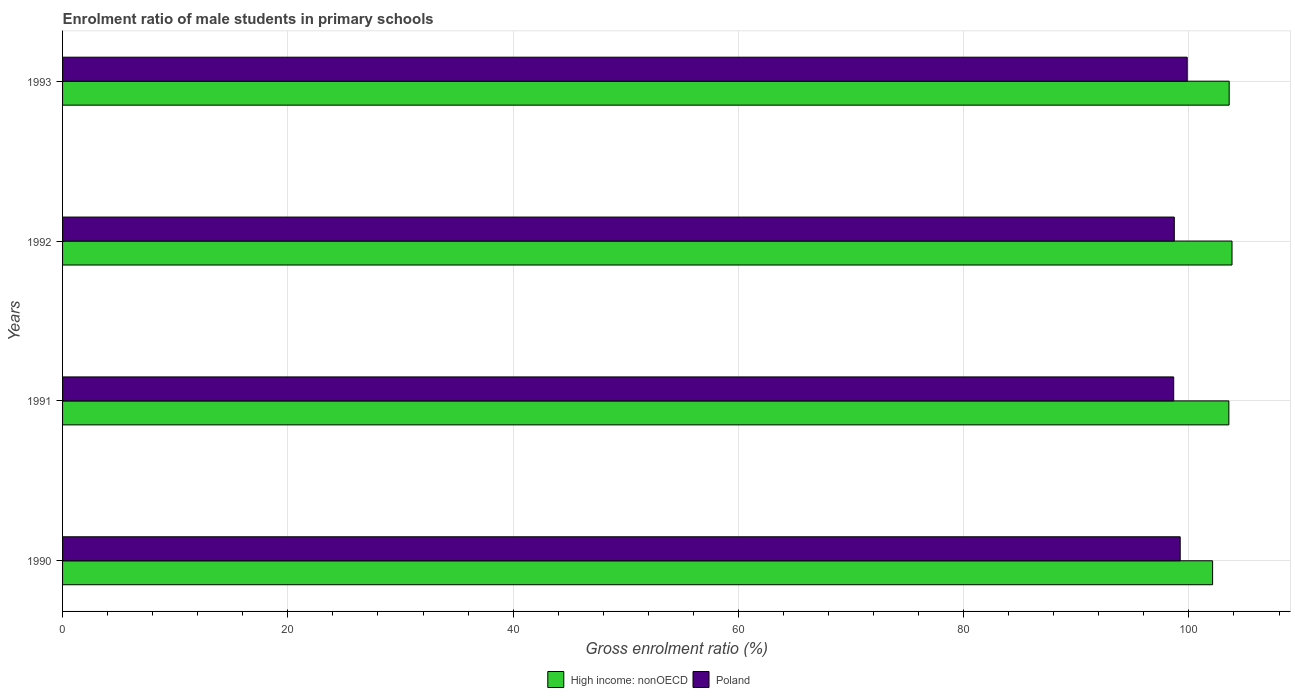How many different coloured bars are there?
Your response must be concise. 2. How many bars are there on the 3rd tick from the bottom?
Give a very brief answer. 2. What is the label of the 4th group of bars from the top?
Keep it short and to the point. 1990. In how many cases, is the number of bars for a given year not equal to the number of legend labels?
Provide a short and direct response. 0. What is the enrolment ratio of male students in primary schools in High income: nonOECD in 1991?
Provide a succinct answer. 103.54. Across all years, what is the maximum enrolment ratio of male students in primary schools in High income: nonOECD?
Ensure brevity in your answer.  103.83. Across all years, what is the minimum enrolment ratio of male students in primary schools in Poland?
Make the answer very short. 98.65. In which year was the enrolment ratio of male students in primary schools in High income: nonOECD maximum?
Your answer should be very brief. 1992. What is the total enrolment ratio of male students in primary schools in High income: nonOECD in the graph?
Provide a succinct answer. 413.04. What is the difference between the enrolment ratio of male students in primary schools in Poland in 1991 and that in 1993?
Provide a succinct answer. -1.2. What is the difference between the enrolment ratio of male students in primary schools in High income: nonOECD in 1990 and the enrolment ratio of male students in primary schools in Poland in 1991?
Your answer should be compact. 3.45. What is the average enrolment ratio of male students in primary schools in Poland per year?
Keep it short and to the point. 99.11. In the year 1991, what is the difference between the enrolment ratio of male students in primary schools in Poland and enrolment ratio of male students in primary schools in High income: nonOECD?
Offer a very short reply. -4.9. What is the ratio of the enrolment ratio of male students in primary schools in Poland in 1992 to that in 1993?
Keep it short and to the point. 0.99. What is the difference between the highest and the second highest enrolment ratio of male students in primary schools in Poland?
Make the answer very short. 0.62. What is the difference between the highest and the lowest enrolment ratio of male students in primary schools in High income: nonOECD?
Provide a succinct answer. 1.72. In how many years, is the enrolment ratio of male students in primary schools in Poland greater than the average enrolment ratio of male students in primary schools in Poland taken over all years?
Make the answer very short. 2. What does the 1st bar from the bottom in 1990 represents?
Ensure brevity in your answer.  High income: nonOECD. How many years are there in the graph?
Provide a short and direct response. 4. Does the graph contain grids?
Your answer should be very brief. Yes. How are the legend labels stacked?
Ensure brevity in your answer.  Horizontal. What is the title of the graph?
Make the answer very short. Enrolment ratio of male students in primary schools. Does "Nigeria" appear as one of the legend labels in the graph?
Provide a succinct answer. No. What is the label or title of the X-axis?
Offer a terse response. Gross enrolment ratio (%). What is the label or title of the Y-axis?
Your answer should be very brief. Years. What is the Gross enrolment ratio (%) of High income: nonOECD in 1990?
Your answer should be very brief. 102.1. What is the Gross enrolment ratio (%) in Poland in 1990?
Ensure brevity in your answer.  99.23. What is the Gross enrolment ratio (%) of High income: nonOECD in 1991?
Your response must be concise. 103.54. What is the Gross enrolment ratio (%) of Poland in 1991?
Your response must be concise. 98.65. What is the Gross enrolment ratio (%) of High income: nonOECD in 1992?
Your answer should be compact. 103.83. What is the Gross enrolment ratio (%) in Poland in 1992?
Your response must be concise. 98.7. What is the Gross enrolment ratio (%) of High income: nonOECD in 1993?
Your answer should be very brief. 103.57. What is the Gross enrolment ratio (%) in Poland in 1993?
Provide a short and direct response. 99.85. Across all years, what is the maximum Gross enrolment ratio (%) of High income: nonOECD?
Offer a terse response. 103.83. Across all years, what is the maximum Gross enrolment ratio (%) of Poland?
Your response must be concise. 99.85. Across all years, what is the minimum Gross enrolment ratio (%) of High income: nonOECD?
Provide a short and direct response. 102.1. Across all years, what is the minimum Gross enrolment ratio (%) of Poland?
Make the answer very short. 98.65. What is the total Gross enrolment ratio (%) of High income: nonOECD in the graph?
Make the answer very short. 413.04. What is the total Gross enrolment ratio (%) of Poland in the graph?
Your answer should be very brief. 396.42. What is the difference between the Gross enrolment ratio (%) of High income: nonOECD in 1990 and that in 1991?
Make the answer very short. -1.44. What is the difference between the Gross enrolment ratio (%) in Poland in 1990 and that in 1991?
Make the answer very short. 0.58. What is the difference between the Gross enrolment ratio (%) in High income: nonOECD in 1990 and that in 1992?
Provide a short and direct response. -1.72. What is the difference between the Gross enrolment ratio (%) in Poland in 1990 and that in 1992?
Give a very brief answer. 0.52. What is the difference between the Gross enrolment ratio (%) of High income: nonOECD in 1990 and that in 1993?
Provide a short and direct response. -1.47. What is the difference between the Gross enrolment ratio (%) in Poland in 1990 and that in 1993?
Provide a short and direct response. -0.62. What is the difference between the Gross enrolment ratio (%) of High income: nonOECD in 1991 and that in 1992?
Your answer should be compact. -0.28. What is the difference between the Gross enrolment ratio (%) of Poland in 1991 and that in 1992?
Provide a short and direct response. -0.05. What is the difference between the Gross enrolment ratio (%) of High income: nonOECD in 1991 and that in 1993?
Keep it short and to the point. -0.03. What is the difference between the Gross enrolment ratio (%) in Poland in 1991 and that in 1993?
Ensure brevity in your answer.  -1.2. What is the difference between the Gross enrolment ratio (%) of High income: nonOECD in 1992 and that in 1993?
Offer a very short reply. 0.25. What is the difference between the Gross enrolment ratio (%) of Poland in 1992 and that in 1993?
Provide a succinct answer. -1.15. What is the difference between the Gross enrolment ratio (%) of High income: nonOECD in 1990 and the Gross enrolment ratio (%) of Poland in 1991?
Your answer should be compact. 3.45. What is the difference between the Gross enrolment ratio (%) of High income: nonOECD in 1990 and the Gross enrolment ratio (%) of Poland in 1992?
Your answer should be very brief. 3.4. What is the difference between the Gross enrolment ratio (%) of High income: nonOECD in 1990 and the Gross enrolment ratio (%) of Poland in 1993?
Provide a succinct answer. 2.25. What is the difference between the Gross enrolment ratio (%) of High income: nonOECD in 1991 and the Gross enrolment ratio (%) of Poland in 1992?
Give a very brief answer. 4.84. What is the difference between the Gross enrolment ratio (%) of High income: nonOECD in 1991 and the Gross enrolment ratio (%) of Poland in 1993?
Provide a succinct answer. 3.7. What is the difference between the Gross enrolment ratio (%) in High income: nonOECD in 1992 and the Gross enrolment ratio (%) in Poland in 1993?
Give a very brief answer. 3.98. What is the average Gross enrolment ratio (%) of High income: nonOECD per year?
Offer a terse response. 103.26. What is the average Gross enrolment ratio (%) in Poland per year?
Make the answer very short. 99.11. In the year 1990, what is the difference between the Gross enrolment ratio (%) in High income: nonOECD and Gross enrolment ratio (%) in Poland?
Your response must be concise. 2.88. In the year 1991, what is the difference between the Gross enrolment ratio (%) in High income: nonOECD and Gross enrolment ratio (%) in Poland?
Provide a short and direct response. 4.9. In the year 1992, what is the difference between the Gross enrolment ratio (%) of High income: nonOECD and Gross enrolment ratio (%) of Poland?
Provide a short and direct response. 5.12. In the year 1993, what is the difference between the Gross enrolment ratio (%) in High income: nonOECD and Gross enrolment ratio (%) in Poland?
Make the answer very short. 3.72. What is the ratio of the Gross enrolment ratio (%) in High income: nonOECD in 1990 to that in 1991?
Ensure brevity in your answer.  0.99. What is the ratio of the Gross enrolment ratio (%) of Poland in 1990 to that in 1991?
Your response must be concise. 1.01. What is the ratio of the Gross enrolment ratio (%) in High income: nonOECD in 1990 to that in 1992?
Your answer should be compact. 0.98. What is the ratio of the Gross enrolment ratio (%) in Poland in 1990 to that in 1992?
Give a very brief answer. 1.01. What is the ratio of the Gross enrolment ratio (%) of High income: nonOECD in 1990 to that in 1993?
Ensure brevity in your answer.  0.99. What is the ratio of the Gross enrolment ratio (%) in Poland in 1990 to that in 1993?
Offer a very short reply. 0.99. What is the ratio of the Gross enrolment ratio (%) in High income: nonOECD in 1991 to that in 1992?
Your answer should be compact. 1. What is the ratio of the Gross enrolment ratio (%) in Poland in 1991 to that in 1993?
Your answer should be compact. 0.99. What is the ratio of the Gross enrolment ratio (%) in Poland in 1992 to that in 1993?
Keep it short and to the point. 0.99. What is the difference between the highest and the second highest Gross enrolment ratio (%) in High income: nonOECD?
Ensure brevity in your answer.  0.25. What is the difference between the highest and the second highest Gross enrolment ratio (%) of Poland?
Your answer should be compact. 0.62. What is the difference between the highest and the lowest Gross enrolment ratio (%) in High income: nonOECD?
Make the answer very short. 1.72. What is the difference between the highest and the lowest Gross enrolment ratio (%) in Poland?
Your response must be concise. 1.2. 